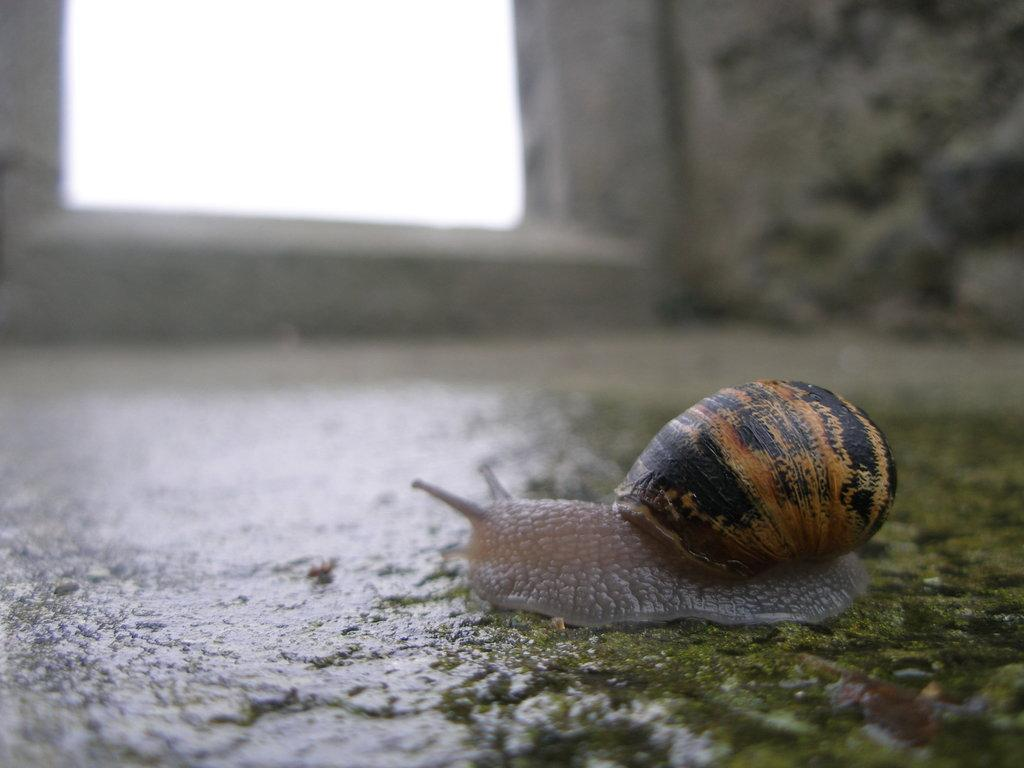What is the main subject of the image? There is a snail in the image. Where is the snail located? The snail is on the ground. What can be seen in the background of the image? There is a wall in the background of the image. How would you describe the background of the image? The background of the image is blurred. What time of day is it in the image? The time of day cannot be determined from the image, as there are no indicators of time present. 